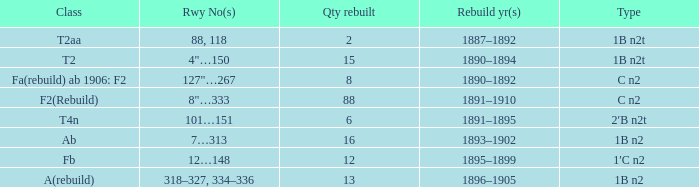What was the Rebuildjahr(e) for the T2AA class? 1887–1892. 